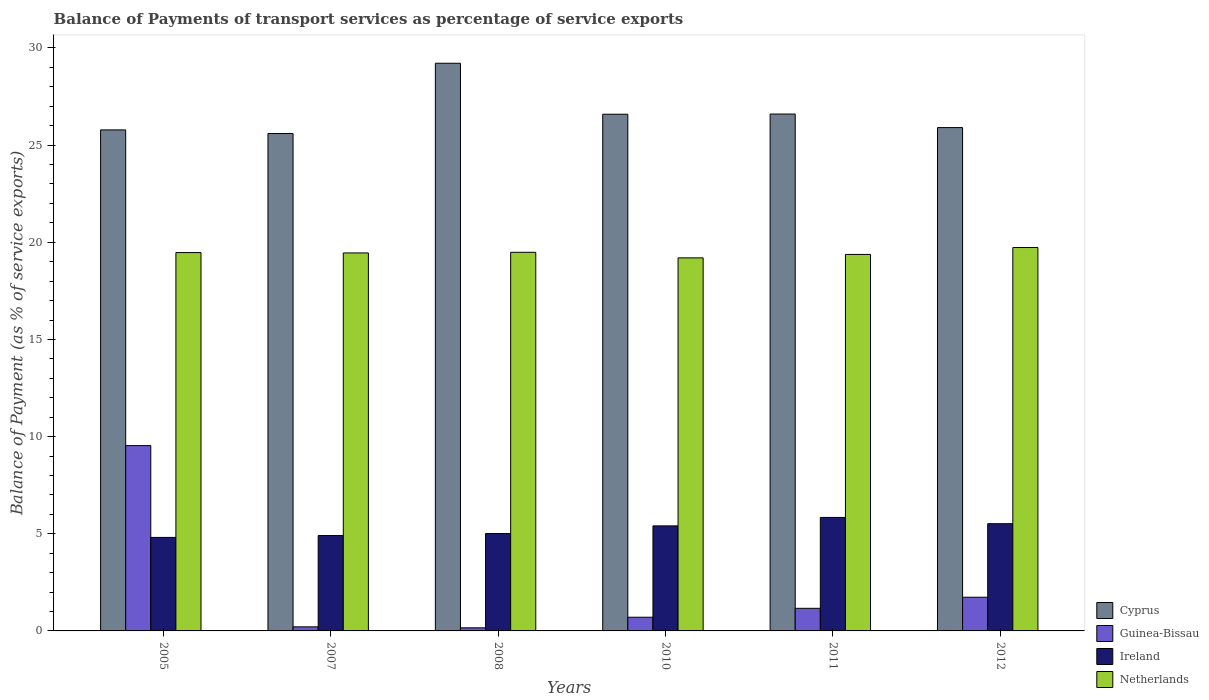Are the number of bars on each tick of the X-axis equal?
Keep it short and to the point. Yes. In how many cases, is the number of bars for a given year not equal to the number of legend labels?
Give a very brief answer. 0. What is the balance of payments of transport services in Netherlands in 2011?
Give a very brief answer. 19.37. Across all years, what is the maximum balance of payments of transport services in Netherlands?
Give a very brief answer. 19.73. Across all years, what is the minimum balance of payments of transport services in Ireland?
Give a very brief answer. 4.81. In which year was the balance of payments of transport services in Ireland maximum?
Ensure brevity in your answer.  2011. What is the total balance of payments of transport services in Ireland in the graph?
Your response must be concise. 31.5. What is the difference between the balance of payments of transport services in Guinea-Bissau in 2005 and that in 2011?
Keep it short and to the point. 8.37. What is the difference between the balance of payments of transport services in Netherlands in 2005 and the balance of payments of transport services in Ireland in 2012?
Provide a short and direct response. 13.95. What is the average balance of payments of transport services in Ireland per year?
Your response must be concise. 5.25. In the year 2007, what is the difference between the balance of payments of transport services in Cyprus and balance of payments of transport services in Netherlands?
Provide a succinct answer. 6.14. In how many years, is the balance of payments of transport services in Cyprus greater than 13 %?
Give a very brief answer. 6. What is the ratio of the balance of payments of transport services in Ireland in 2007 to that in 2012?
Provide a succinct answer. 0.89. Is the difference between the balance of payments of transport services in Cyprus in 2005 and 2012 greater than the difference between the balance of payments of transport services in Netherlands in 2005 and 2012?
Keep it short and to the point. Yes. What is the difference between the highest and the second highest balance of payments of transport services in Netherlands?
Ensure brevity in your answer.  0.25. What is the difference between the highest and the lowest balance of payments of transport services in Cyprus?
Offer a terse response. 3.62. In how many years, is the balance of payments of transport services in Netherlands greater than the average balance of payments of transport services in Netherlands taken over all years?
Your response must be concise. 4. Is the sum of the balance of payments of transport services in Ireland in 2007 and 2011 greater than the maximum balance of payments of transport services in Cyprus across all years?
Keep it short and to the point. No. Is it the case that in every year, the sum of the balance of payments of transport services in Cyprus and balance of payments of transport services in Ireland is greater than the sum of balance of payments of transport services in Guinea-Bissau and balance of payments of transport services in Netherlands?
Offer a very short reply. No. What does the 3rd bar from the left in 2012 represents?
Your answer should be very brief. Ireland. What does the 4th bar from the right in 2010 represents?
Provide a short and direct response. Cyprus. How many bars are there?
Your response must be concise. 24. What is the difference between two consecutive major ticks on the Y-axis?
Your answer should be very brief. 5. How many legend labels are there?
Your answer should be compact. 4. How are the legend labels stacked?
Your response must be concise. Vertical. What is the title of the graph?
Your answer should be very brief. Balance of Payments of transport services as percentage of service exports. What is the label or title of the Y-axis?
Your answer should be very brief. Balance of Payment (as % of service exports). What is the Balance of Payment (as % of service exports) of Cyprus in 2005?
Make the answer very short. 25.78. What is the Balance of Payment (as % of service exports) in Guinea-Bissau in 2005?
Make the answer very short. 9.54. What is the Balance of Payment (as % of service exports) of Ireland in 2005?
Give a very brief answer. 4.81. What is the Balance of Payment (as % of service exports) in Netherlands in 2005?
Make the answer very short. 19.47. What is the Balance of Payment (as % of service exports) of Cyprus in 2007?
Provide a short and direct response. 25.6. What is the Balance of Payment (as % of service exports) of Guinea-Bissau in 2007?
Provide a succinct answer. 0.21. What is the Balance of Payment (as % of service exports) in Ireland in 2007?
Give a very brief answer. 4.91. What is the Balance of Payment (as % of service exports) of Netherlands in 2007?
Make the answer very short. 19.45. What is the Balance of Payment (as % of service exports) in Cyprus in 2008?
Give a very brief answer. 29.21. What is the Balance of Payment (as % of service exports) of Guinea-Bissau in 2008?
Offer a terse response. 0.16. What is the Balance of Payment (as % of service exports) in Ireland in 2008?
Offer a terse response. 5.01. What is the Balance of Payment (as % of service exports) of Netherlands in 2008?
Provide a succinct answer. 19.48. What is the Balance of Payment (as % of service exports) in Cyprus in 2010?
Make the answer very short. 26.59. What is the Balance of Payment (as % of service exports) in Guinea-Bissau in 2010?
Make the answer very short. 0.7. What is the Balance of Payment (as % of service exports) in Ireland in 2010?
Keep it short and to the point. 5.4. What is the Balance of Payment (as % of service exports) in Netherlands in 2010?
Provide a succinct answer. 19.2. What is the Balance of Payment (as % of service exports) in Cyprus in 2011?
Ensure brevity in your answer.  26.6. What is the Balance of Payment (as % of service exports) in Guinea-Bissau in 2011?
Give a very brief answer. 1.16. What is the Balance of Payment (as % of service exports) in Ireland in 2011?
Offer a terse response. 5.84. What is the Balance of Payment (as % of service exports) in Netherlands in 2011?
Your answer should be compact. 19.37. What is the Balance of Payment (as % of service exports) of Cyprus in 2012?
Your answer should be compact. 25.9. What is the Balance of Payment (as % of service exports) of Guinea-Bissau in 2012?
Your response must be concise. 1.73. What is the Balance of Payment (as % of service exports) of Ireland in 2012?
Provide a short and direct response. 5.52. What is the Balance of Payment (as % of service exports) of Netherlands in 2012?
Keep it short and to the point. 19.73. Across all years, what is the maximum Balance of Payment (as % of service exports) in Cyprus?
Ensure brevity in your answer.  29.21. Across all years, what is the maximum Balance of Payment (as % of service exports) in Guinea-Bissau?
Your answer should be compact. 9.54. Across all years, what is the maximum Balance of Payment (as % of service exports) of Ireland?
Your response must be concise. 5.84. Across all years, what is the maximum Balance of Payment (as % of service exports) of Netherlands?
Offer a terse response. 19.73. Across all years, what is the minimum Balance of Payment (as % of service exports) of Cyprus?
Keep it short and to the point. 25.6. Across all years, what is the minimum Balance of Payment (as % of service exports) of Guinea-Bissau?
Ensure brevity in your answer.  0.16. Across all years, what is the minimum Balance of Payment (as % of service exports) in Ireland?
Give a very brief answer. 4.81. Across all years, what is the minimum Balance of Payment (as % of service exports) of Netherlands?
Your response must be concise. 19.2. What is the total Balance of Payment (as % of service exports) in Cyprus in the graph?
Offer a terse response. 159.68. What is the total Balance of Payment (as % of service exports) of Guinea-Bissau in the graph?
Your response must be concise. 13.51. What is the total Balance of Payment (as % of service exports) of Ireland in the graph?
Offer a very short reply. 31.5. What is the total Balance of Payment (as % of service exports) in Netherlands in the graph?
Ensure brevity in your answer.  116.71. What is the difference between the Balance of Payment (as % of service exports) of Cyprus in 2005 and that in 2007?
Give a very brief answer. 0.19. What is the difference between the Balance of Payment (as % of service exports) of Guinea-Bissau in 2005 and that in 2007?
Keep it short and to the point. 9.33. What is the difference between the Balance of Payment (as % of service exports) of Ireland in 2005 and that in 2007?
Offer a terse response. -0.1. What is the difference between the Balance of Payment (as % of service exports) in Netherlands in 2005 and that in 2007?
Your response must be concise. 0.02. What is the difference between the Balance of Payment (as % of service exports) of Cyprus in 2005 and that in 2008?
Provide a short and direct response. -3.43. What is the difference between the Balance of Payment (as % of service exports) in Guinea-Bissau in 2005 and that in 2008?
Ensure brevity in your answer.  9.38. What is the difference between the Balance of Payment (as % of service exports) in Ireland in 2005 and that in 2008?
Ensure brevity in your answer.  -0.2. What is the difference between the Balance of Payment (as % of service exports) of Netherlands in 2005 and that in 2008?
Your answer should be compact. -0.01. What is the difference between the Balance of Payment (as % of service exports) in Cyprus in 2005 and that in 2010?
Keep it short and to the point. -0.81. What is the difference between the Balance of Payment (as % of service exports) of Guinea-Bissau in 2005 and that in 2010?
Your response must be concise. 8.83. What is the difference between the Balance of Payment (as % of service exports) of Ireland in 2005 and that in 2010?
Your answer should be compact. -0.59. What is the difference between the Balance of Payment (as % of service exports) in Netherlands in 2005 and that in 2010?
Offer a terse response. 0.27. What is the difference between the Balance of Payment (as % of service exports) of Cyprus in 2005 and that in 2011?
Keep it short and to the point. -0.82. What is the difference between the Balance of Payment (as % of service exports) in Guinea-Bissau in 2005 and that in 2011?
Your response must be concise. 8.37. What is the difference between the Balance of Payment (as % of service exports) of Ireland in 2005 and that in 2011?
Make the answer very short. -1.03. What is the difference between the Balance of Payment (as % of service exports) in Netherlands in 2005 and that in 2011?
Your response must be concise. 0.1. What is the difference between the Balance of Payment (as % of service exports) of Cyprus in 2005 and that in 2012?
Offer a terse response. -0.12. What is the difference between the Balance of Payment (as % of service exports) in Guinea-Bissau in 2005 and that in 2012?
Your response must be concise. 7.8. What is the difference between the Balance of Payment (as % of service exports) in Ireland in 2005 and that in 2012?
Your answer should be compact. -0.71. What is the difference between the Balance of Payment (as % of service exports) in Netherlands in 2005 and that in 2012?
Provide a short and direct response. -0.26. What is the difference between the Balance of Payment (as % of service exports) in Cyprus in 2007 and that in 2008?
Ensure brevity in your answer.  -3.62. What is the difference between the Balance of Payment (as % of service exports) of Guinea-Bissau in 2007 and that in 2008?
Offer a terse response. 0.05. What is the difference between the Balance of Payment (as % of service exports) of Ireland in 2007 and that in 2008?
Ensure brevity in your answer.  -0.1. What is the difference between the Balance of Payment (as % of service exports) of Netherlands in 2007 and that in 2008?
Make the answer very short. -0.03. What is the difference between the Balance of Payment (as % of service exports) of Cyprus in 2007 and that in 2010?
Offer a terse response. -0.99. What is the difference between the Balance of Payment (as % of service exports) of Guinea-Bissau in 2007 and that in 2010?
Keep it short and to the point. -0.5. What is the difference between the Balance of Payment (as % of service exports) in Ireland in 2007 and that in 2010?
Offer a very short reply. -0.5. What is the difference between the Balance of Payment (as % of service exports) in Netherlands in 2007 and that in 2010?
Provide a short and direct response. 0.25. What is the difference between the Balance of Payment (as % of service exports) of Cyprus in 2007 and that in 2011?
Offer a very short reply. -1. What is the difference between the Balance of Payment (as % of service exports) in Guinea-Bissau in 2007 and that in 2011?
Ensure brevity in your answer.  -0.95. What is the difference between the Balance of Payment (as % of service exports) of Ireland in 2007 and that in 2011?
Offer a terse response. -0.93. What is the difference between the Balance of Payment (as % of service exports) in Netherlands in 2007 and that in 2011?
Provide a succinct answer. 0.08. What is the difference between the Balance of Payment (as % of service exports) in Cyprus in 2007 and that in 2012?
Offer a very short reply. -0.31. What is the difference between the Balance of Payment (as % of service exports) in Guinea-Bissau in 2007 and that in 2012?
Give a very brief answer. -1.52. What is the difference between the Balance of Payment (as % of service exports) of Ireland in 2007 and that in 2012?
Ensure brevity in your answer.  -0.61. What is the difference between the Balance of Payment (as % of service exports) of Netherlands in 2007 and that in 2012?
Give a very brief answer. -0.28. What is the difference between the Balance of Payment (as % of service exports) in Cyprus in 2008 and that in 2010?
Your answer should be compact. 2.62. What is the difference between the Balance of Payment (as % of service exports) in Guinea-Bissau in 2008 and that in 2010?
Offer a terse response. -0.54. What is the difference between the Balance of Payment (as % of service exports) in Ireland in 2008 and that in 2010?
Your answer should be compact. -0.39. What is the difference between the Balance of Payment (as % of service exports) of Netherlands in 2008 and that in 2010?
Make the answer very short. 0.29. What is the difference between the Balance of Payment (as % of service exports) in Cyprus in 2008 and that in 2011?
Offer a terse response. 2.61. What is the difference between the Balance of Payment (as % of service exports) in Guinea-Bissau in 2008 and that in 2011?
Keep it short and to the point. -1. What is the difference between the Balance of Payment (as % of service exports) in Ireland in 2008 and that in 2011?
Keep it short and to the point. -0.83. What is the difference between the Balance of Payment (as % of service exports) of Netherlands in 2008 and that in 2011?
Ensure brevity in your answer.  0.11. What is the difference between the Balance of Payment (as % of service exports) in Cyprus in 2008 and that in 2012?
Offer a terse response. 3.31. What is the difference between the Balance of Payment (as % of service exports) in Guinea-Bissau in 2008 and that in 2012?
Offer a terse response. -1.57. What is the difference between the Balance of Payment (as % of service exports) in Ireland in 2008 and that in 2012?
Make the answer very short. -0.51. What is the difference between the Balance of Payment (as % of service exports) of Netherlands in 2008 and that in 2012?
Offer a terse response. -0.25. What is the difference between the Balance of Payment (as % of service exports) of Cyprus in 2010 and that in 2011?
Make the answer very short. -0.01. What is the difference between the Balance of Payment (as % of service exports) in Guinea-Bissau in 2010 and that in 2011?
Offer a very short reply. -0.46. What is the difference between the Balance of Payment (as % of service exports) in Ireland in 2010 and that in 2011?
Offer a terse response. -0.44. What is the difference between the Balance of Payment (as % of service exports) in Netherlands in 2010 and that in 2011?
Provide a short and direct response. -0.18. What is the difference between the Balance of Payment (as % of service exports) in Cyprus in 2010 and that in 2012?
Your answer should be very brief. 0.69. What is the difference between the Balance of Payment (as % of service exports) of Guinea-Bissau in 2010 and that in 2012?
Give a very brief answer. -1.03. What is the difference between the Balance of Payment (as % of service exports) in Ireland in 2010 and that in 2012?
Ensure brevity in your answer.  -0.11. What is the difference between the Balance of Payment (as % of service exports) of Netherlands in 2010 and that in 2012?
Offer a terse response. -0.53. What is the difference between the Balance of Payment (as % of service exports) of Cyprus in 2011 and that in 2012?
Offer a terse response. 0.7. What is the difference between the Balance of Payment (as % of service exports) of Guinea-Bissau in 2011 and that in 2012?
Your answer should be very brief. -0.57. What is the difference between the Balance of Payment (as % of service exports) in Ireland in 2011 and that in 2012?
Give a very brief answer. 0.32. What is the difference between the Balance of Payment (as % of service exports) in Netherlands in 2011 and that in 2012?
Offer a terse response. -0.36. What is the difference between the Balance of Payment (as % of service exports) of Cyprus in 2005 and the Balance of Payment (as % of service exports) of Guinea-Bissau in 2007?
Make the answer very short. 25.57. What is the difference between the Balance of Payment (as % of service exports) of Cyprus in 2005 and the Balance of Payment (as % of service exports) of Ireland in 2007?
Your answer should be very brief. 20.87. What is the difference between the Balance of Payment (as % of service exports) of Cyprus in 2005 and the Balance of Payment (as % of service exports) of Netherlands in 2007?
Your response must be concise. 6.33. What is the difference between the Balance of Payment (as % of service exports) in Guinea-Bissau in 2005 and the Balance of Payment (as % of service exports) in Ireland in 2007?
Give a very brief answer. 4.63. What is the difference between the Balance of Payment (as % of service exports) of Guinea-Bissau in 2005 and the Balance of Payment (as % of service exports) of Netherlands in 2007?
Offer a very short reply. -9.91. What is the difference between the Balance of Payment (as % of service exports) of Ireland in 2005 and the Balance of Payment (as % of service exports) of Netherlands in 2007?
Offer a very short reply. -14.64. What is the difference between the Balance of Payment (as % of service exports) of Cyprus in 2005 and the Balance of Payment (as % of service exports) of Guinea-Bissau in 2008?
Keep it short and to the point. 25.62. What is the difference between the Balance of Payment (as % of service exports) in Cyprus in 2005 and the Balance of Payment (as % of service exports) in Ireland in 2008?
Offer a very short reply. 20.77. What is the difference between the Balance of Payment (as % of service exports) in Cyprus in 2005 and the Balance of Payment (as % of service exports) in Netherlands in 2008?
Provide a short and direct response. 6.3. What is the difference between the Balance of Payment (as % of service exports) in Guinea-Bissau in 2005 and the Balance of Payment (as % of service exports) in Ireland in 2008?
Offer a very short reply. 4.53. What is the difference between the Balance of Payment (as % of service exports) of Guinea-Bissau in 2005 and the Balance of Payment (as % of service exports) of Netherlands in 2008?
Provide a succinct answer. -9.95. What is the difference between the Balance of Payment (as % of service exports) in Ireland in 2005 and the Balance of Payment (as % of service exports) in Netherlands in 2008?
Offer a very short reply. -14.67. What is the difference between the Balance of Payment (as % of service exports) of Cyprus in 2005 and the Balance of Payment (as % of service exports) of Guinea-Bissau in 2010?
Your response must be concise. 25.08. What is the difference between the Balance of Payment (as % of service exports) in Cyprus in 2005 and the Balance of Payment (as % of service exports) in Ireland in 2010?
Ensure brevity in your answer.  20.38. What is the difference between the Balance of Payment (as % of service exports) of Cyprus in 2005 and the Balance of Payment (as % of service exports) of Netherlands in 2010?
Offer a terse response. 6.59. What is the difference between the Balance of Payment (as % of service exports) of Guinea-Bissau in 2005 and the Balance of Payment (as % of service exports) of Ireland in 2010?
Give a very brief answer. 4.13. What is the difference between the Balance of Payment (as % of service exports) of Guinea-Bissau in 2005 and the Balance of Payment (as % of service exports) of Netherlands in 2010?
Provide a short and direct response. -9.66. What is the difference between the Balance of Payment (as % of service exports) in Ireland in 2005 and the Balance of Payment (as % of service exports) in Netherlands in 2010?
Give a very brief answer. -14.38. What is the difference between the Balance of Payment (as % of service exports) in Cyprus in 2005 and the Balance of Payment (as % of service exports) in Guinea-Bissau in 2011?
Provide a short and direct response. 24.62. What is the difference between the Balance of Payment (as % of service exports) in Cyprus in 2005 and the Balance of Payment (as % of service exports) in Ireland in 2011?
Provide a short and direct response. 19.94. What is the difference between the Balance of Payment (as % of service exports) in Cyprus in 2005 and the Balance of Payment (as % of service exports) in Netherlands in 2011?
Your answer should be very brief. 6.41. What is the difference between the Balance of Payment (as % of service exports) of Guinea-Bissau in 2005 and the Balance of Payment (as % of service exports) of Ireland in 2011?
Your answer should be very brief. 3.7. What is the difference between the Balance of Payment (as % of service exports) of Guinea-Bissau in 2005 and the Balance of Payment (as % of service exports) of Netherlands in 2011?
Your answer should be very brief. -9.84. What is the difference between the Balance of Payment (as % of service exports) in Ireland in 2005 and the Balance of Payment (as % of service exports) in Netherlands in 2011?
Make the answer very short. -14.56. What is the difference between the Balance of Payment (as % of service exports) in Cyprus in 2005 and the Balance of Payment (as % of service exports) in Guinea-Bissau in 2012?
Provide a succinct answer. 24.05. What is the difference between the Balance of Payment (as % of service exports) in Cyprus in 2005 and the Balance of Payment (as % of service exports) in Ireland in 2012?
Provide a short and direct response. 20.26. What is the difference between the Balance of Payment (as % of service exports) of Cyprus in 2005 and the Balance of Payment (as % of service exports) of Netherlands in 2012?
Offer a very short reply. 6.05. What is the difference between the Balance of Payment (as % of service exports) of Guinea-Bissau in 2005 and the Balance of Payment (as % of service exports) of Ireland in 2012?
Your answer should be very brief. 4.02. What is the difference between the Balance of Payment (as % of service exports) in Guinea-Bissau in 2005 and the Balance of Payment (as % of service exports) in Netherlands in 2012?
Offer a very short reply. -10.19. What is the difference between the Balance of Payment (as % of service exports) in Ireland in 2005 and the Balance of Payment (as % of service exports) in Netherlands in 2012?
Your answer should be compact. -14.92. What is the difference between the Balance of Payment (as % of service exports) of Cyprus in 2007 and the Balance of Payment (as % of service exports) of Guinea-Bissau in 2008?
Your answer should be compact. 25.44. What is the difference between the Balance of Payment (as % of service exports) in Cyprus in 2007 and the Balance of Payment (as % of service exports) in Ireland in 2008?
Your answer should be very brief. 20.58. What is the difference between the Balance of Payment (as % of service exports) of Cyprus in 2007 and the Balance of Payment (as % of service exports) of Netherlands in 2008?
Your answer should be compact. 6.11. What is the difference between the Balance of Payment (as % of service exports) of Guinea-Bissau in 2007 and the Balance of Payment (as % of service exports) of Ireland in 2008?
Make the answer very short. -4.8. What is the difference between the Balance of Payment (as % of service exports) in Guinea-Bissau in 2007 and the Balance of Payment (as % of service exports) in Netherlands in 2008?
Offer a terse response. -19.27. What is the difference between the Balance of Payment (as % of service exports) in Ireland in 2007 and the Balance of Payment (as % of service exports) in Netherlands in 2008?
Give a very brief answer. -14.58. What is the difference between the Balance of Payment (as % of service exports) in Cyprus in 2007 and the Balance of Payment (as % of service exports) in Guinea-Bissau in 2010?
Give a very brief answer. 24.89. What is the difference between the Balance of Payment (as % of service exports) of Cyprus in 2007 and the Balance of Payment (as % of service exports) of Ireland in 2010?
Provide a short and direct response. 20.19. What is the difference between the Balance of Payment (as % of service exports) in Cyprus in 2007 and the Balance of Payment (as % of service exports) in Netherlands in 2010?
Your answer should be very brief. 6.4. What is the difference between the Balance of Payment (as % of service exports) in Guinea-Bissau in 2007 and the Balance of Payment (as % of service exports) in Ireland in 2010?
Your answer should be compact. -5.2. What is the difference between the Balance of Payment (as % of service exports) of Guinea-Bissau in 2007 and the Balance of Payment (as % of service exports) of Netherlands in 2010?
Make the answer very short. -18.99. What is the difference between the Balance of Payment (as % of service exports) of Ireland in 2007 and the Balance of Payment (as % of service exports) of Netherlands in 2010?
Make the answer very short. -14.29. What is the difference between the Balance of Payment (as % of service exports) in Cyprus in 2007 and the Balance of Payment (as % of service exports) in Guinea-Bissau in 2011?
Ensure brevity in your answer.  24.43. What is the difference between the Balance of Payment (as % of service exports) in Cyprus in 2007 and the Balance of Payment (as % of service exports) in Ireland in 2011?
Ensure brevity in your answer.  19.75. What is the difference between the Balance of Payment (as % of service exports) of Cyprus in 2007 and the Balance of Payment (as % of service exports) of Netherlands in 2011?
Offer a terse response. 6.22. What is the difference between the Balance of Payment (as % of service exports) in Guinea-Bissau in 2007 and the Balance of Payment (as % of service exports) in Ireland in 2011?
Your answer should be very brief. -5.63. What is the difference between the Balance of Payment (as % of service exports) of Guinea-Bissau in 2007 and the Balance of Payment (as % of service exports) of Netherlands in 2011?
Give a very brief answer. -19.16. What is the difference between the Balance of Payment (as % of service exports) of Ireland in 2007 and the Balance of Payment (as % of service exports) of Netherlands in 2011?
Give a very brief answer. -14.47. What is the difference between the Balance of Payment (as % of service exports) in Cyprus in 2007 and the Balance of Payment (as % of service exports) in Guinea-Bissau in 2012?
Provide a short and direct response. 23.86. What is the difference between the Balance of Payment (as % of service exports) in Cyprus in 2007 and the Balance of Payment (as % of service exports) in Ireland in 2012?
Keep it short and to the point. 20.08. What is the difference between the Balance of Payment (as % of service exports) in Cyprus in 2007 and the Balance of Payment (as % of service exports) in Netherlands in 2012?
Provide a succinct answer. 5.87. What is the difference between the Balance of Payment (as % of service exports) in Guinea-Bissau in 2007 and the Balance of Payment (as % of service exports) in Ireland in 2012?
Give a very brief answer. -5.31. What is the difference between the Balance of Payment (as % of service exports) in Guinea-Bissau in 2007 and the Balance of Payment (as % of service exports) in Netherlands in 2012?
Provide a succinct answer. -19.52. What is the difference between the Balance of Payment (as % of service exports) in Ireland in 2007 and the Balance of Payment (as % of service exports) in Netherlands in 2012?
Make the answer very short. -14.82. What is the difference between the Balance of Payment (as % of service exports) of Cyprus in 2008 and the Balance of Payment (as % of service exports) of Guinea-Bissau in 2010?
Provide a succinct answer. 28.51. What is the difference between the Balance of Payment (as % of service exports) in Cyprus in 2008 and the Balance of Payment (as % of service exports) in Ireland in 2010?
Ensure brevity in your answer.  23.81. What is the difference between the Balance of Payment (as % of service exports) of Cyprus in 2008 and the Balance of Payment (as % of service exports) of Netherlands in 2010?
Offer a terse response. 10.02. What is the difference between the Balance of Payment (as % of service exports) of Guinea-Bissau in 2008 and the Balance of Payment (as % of service exports) of Ireland in 2010?
Give a very brief answer. -5.25. What is the difference between the Balance of Payment (as % of service exports) of Guinea-Bissau in 2008 and the Balance of Payment (as % of service exports) of Netherlands in 2010?
Give a very brief answer. -19.04. What is the difference between the Balance of Payment (as % of service exports) in Ireland in 2008 and the Balance of Payment (as % of service exports) in Netherlands in 2010?
Provide a succinct answer. -14.18. What is the difference between the Balance of Payment (as % of service exports) in Cyprus in 2008 and the Balance of Payment (as % of service exports) in Guinea-Bissau in 2011?
Ensure brevity in your answer.  28.05. What is the difference between the Balance of Payment (as % of service exports) in Cyprus in 2008 and the Balance of Payment (as % of service exports) in Ireland in 2011?
Make the answer very short. 23.37. What is the difference between the Balance of Payment (as % of service exports) in Cyprus in 2008 and the Balance of Payment (as % of service exports) in Netherlands in 2011?
Provide a succinct answer. 9.84. What is the difference between the Balance of Payment (as % of service exports) in Guinea-Bissau in 2008 and the Balance of Payment (as % of service exports) in Ireland in 2011?
Provide a succinct answer. -5.68. What is the difference between the Balance of Payment (as % of service exports) in Guinea-Bissau in 2008 and the Balance of Payment (as % of service exports) in Netherlands in 2011?
Your answer should be very brief. -19.21. What is the difference between the Balance of Payment (as % of service exports) in Ireland in 2008 and the Balance of Payment (as % of service exports) in Netherlands in 2011?
Offer a terse response. -14.36. What is the difference between the Balance of Payment (as % of service exports) in Cyprus in 2008 and the Balance of Payment (as % of service exports) in Guinea-Bissau in 2012?
Make the answer very short. 27.48. What is the difference between the Balance of Payment (as % of service exports) in Cyprus in 2008 and the Balance of Payment (as % of service exports) in Ireland in 2012?
Your answer should be compact. 23.69. What is the difference between the Balance of Payment (as % of service exports) of Cyprus in 2008 and the Balance of Payment (as % of service exports) of Netherlands in 2012?
Ensure brevity in your answer.  9.48. What is the difference between the Balance of Payment (as % of service exports) of Guinea-Bissau in 2008 and the Balance of Payment (as % of service exports) of Ireland in 2012?
Keep it short and to the point. -5.36. What is the difference between the Balance of Payment (as % of service exports) of Guinea-Bissau in 2008 and the Balance of Payment (as % of service exports) of Netherlands in 2012?
Your answer should be compact. -19.57. What is the difference between the Balance of Payment (as % of service exports) of Ireland in 2008 and the Balance of Payment (as % of service exports) of Netherlands in 2012?
Provide a short and direct response. -14.72. What is the difference between the Balance of Payment (as % of service exports) of Cyprus in 2010 and the Balance of Payment (as % of service exports) of Guinea-Bissau in 2011?
Provide a short and direct response. 25.43. What is the difference between the Balance of Payment (as % of service exports) of Cyprus in 2010 and the Balance of Payment (as % of service exports) of Ireland in 2011?
Ensure brevity in your answer.  20.75. What is the difference between the Balance of Payment (as % of service exports) in Cyprus in 2010 and the Balance of Payment (as % of service exports) in Netherlands in 2011?
Keep it short and to the point. 7.22. What is the difference between the Balance of Payment (as % of service exports) of Guinea-Bissau in 2010 and the Balance of Payment (as % of service exports) of Ireland in 2011?
Offer a very short reply. -5.14. What is the difference between the Balance of Payment (as % of service exports) of Guinea-Bissau in 2010 and the Balance of Payment (as % of service exports) of Netherlands in 2011?
Provide a succinct answer. -18.67. What is the difference between the Balance of Payment (as % of service exports) in Ireland in 2010 and the Balance of Payment (as % of service exports) in Netherlands in 2011?
Give a very brief answer. -13.97. What is the difference between the Balance of Payment (as % of service exports) in Cyprus in 2010 and the Balance of Payment (as % of service exports) in Guinea-Bissau in 2012?
Offer a very short reply. 24.86. What is the difference between the Balance of Payment (as % of service exports) of Cyprus in 2010 and the Balance of Payment (as % of service exports) of Ireland in 2012?
Your response must be concise. 21.07. What is the difference between the Balance of Payment (as % of service exports) in Cyprus in 2010 and the Balance of Payment (as % of service exports) in Netherlands in 2012?
Make the answer very short. 6.86. What is the difference between the Balance of Payment (as % of service exports) of Guinea-Bissau in 2010 and the Balance of Payment (as % of service exports) of Ireland in 2012?
Give a very brief answer. -4.81. What is the difference between the Balance of Payment (as % of service exports) in Guinea-Bissau in 2010 and the Balance of Payment (as % of service exports) in Netherlands in 2012?
Keep it short and to the point. -19.03. What is the difference between the Balance of Payment (as % of service exports) of Ireland in 2010 and the Balance of Payment (as % of service exports) of Netherlands in 2012?
Make the answer very short. -14.32. What is the difference between the Balance of Payment (as % of service exports) of Cyprus in 2011 and the Balance of Payment (as % of service exports) of Guinea-Bissau in 2012?
Provide a succinct answer. 24.87. What is the difference between the Balance of Payment (as % of service exports) in Cyprus in 2011 and the Balance of Payment (as % of service exports) in Ireland in 2012?
Your answer should be compact. 21.08. What is the difference between the Balance of Payment (as % of service exports) in Cyprus in 2011 and the Balance of Payment (as % of service exports) in Netherlands in 2012?
Give a very brief answer. 6.87. What is the difference between the Balance of Payment (as % of service exports) in Guinea-Bissau in 2011 and the Balance of Payment (as % of service exports) in Ireland in 2012?
Keep it short and to the point. -4.36. What is the difference between the Balance of Payment (as % of service exports) in Guinea-Bissau in 2011 and the Balance of Payment (as % of service exports) in Netherlands in 2012?
Provide a succinct answer. -18.57. What is the difference between the Balance of Payment (as % of service exports) in Ireland in 2011 and the Balance of Payment (as % of service exports) in Netherlands in 2012?
Your response must be concise. -13.89. What is the average Balance of Payment (as % of service exports) in Cyprus per year?
Make the answer very short. 26.61. What is the average Balance of Payment (as % of service exports) of Guinea-Bissau per year?
Provide a short and direct response. 2.25. What is the average Balance of Payment (as % of service exports) in Ireland per year?
Offer a very short reply. 5.25. What is the average Balance of Payment (as % of service exports) of Netherlands per year?
Your answer should be compact. 19.45. In the year 2005, what is the difference between the Balance of Payment (as % of service exports) in Cyprus and Balance of Payment (as % of service exports) in Guinea-Bissau?
Offer a very short reply. 16.25. In the year 2005, what is the difference between the Balance of Payment (as % of service exports) of Cyprus and Balance of Payment (as % of service exports) of Ireland?
Keep it short and to the point. 20.97. In the year 2005, what is the difference between the Balance of Payment (as % of service exports) in Cyprus and Balance of Payment (as % of service exports) in Netherlands?
Provide a succinct answer. 6.31. In the year 2005, what is the difference between the Balance of Payment (as % of service exports) in Guinea-Bissau and Balance of Payment (as % of service exports) in Ireland?
Your answer should be very brief. 4.73. In the year 2005, what is the difference between the Balance of Payment (as % of service exports) in Guinea-Bissau and Balance of Payment (as % of service exports) in Netherlands?
Your answer should be very brief. -9.93. In the year 2005, what is the difference between the Balance of Payment (as % of service exports) of Ireland and Balance of Payment (as % of service exports) of Netherlands?
Your answer should be very brief. -14.66. In the year 2007, what is the difference between the Balance of Payment (as % of service exports) in Cyprus and Balance of Payment (as % of service exports) in Guinea-Bissau?
Give a very brief answer. 25.39. In the year 2007, what is the difference between the Balance of Payment (as % of service exports) in Cyprus and Balance of Payment (as % of service exports) in Ireland?
Give a very brief answer. 20.69. In the year 2007, what is the difference between the Balance of Payment (as % of service exports) in Cyprus and Balance of Payment (as % of service exports) in Netherlands?
Make the answer very short. 6.14. In the year 2007, what is the difference between the Balance of Payment (as % of service exports) of Guinea-Bissau and Balance of Payment (as % of service exports) of Ireland?
Make the answer very short. -4.7. In the year 2007, what is the difference between the Balance of Payment (as % of service exports) in Guinea-Bissau and Balance of Payment (as % of service exports) in Netherlands?
Offer a terse response. -19.24. In the year 2007, what is the difference between the Balance of Payment (as % of service exports) of Ireland and Balance of Payment (as % of service exports) of Netherlands?
Make the answer very short. -14.54. In the year 2008, what is the difference between the Balance of Payment (as % of service exports) of Cyprus and Balance of Payment (as % of service exports) of Guinea-Bissau?
Your answer should be very brief. 29.05. In the year 2008, what is the difference between the Balance of Payment (as % of service exports) in Cyprus and Balance of Payment (as % of service exports) in Ireland?
Provide a succinct answer. 24.2. In the year 2008, what is the difference between the Balance of Payment (as % of service exports) of Cyprus and Balance of Payment (as % of service exports) of Netherlands?
Provide a short and direct response. 9.73. In the year 2008, what is the difference between the Balance of Payment (as % of service exports) of Guinea-Bissau and Balance of Payment (as % of service exports) of Ireland?
Make the answer very short. -4.85. In the year 2008, what is the difference between the Balance of Payment (as % of service exports) of Guinea-Bissau and Balance of Payment (as % of service exports) of Netherlands?
Your answer should be compact. -19.32. In the year 2008, what is the difference between the Balance of Payment (as % of service exports) in Ireland and Balance of Payment (as % of service exports) in Netherlands?
Give a very brief answer. -14.47. In the year 2010, what is the difference between the Balance of Payment (as % of service exports) in Cyprus and Balance of Payment (as % of service exports) in Guinea-Bissau?
Provide a short and direct response. 25.88. In the year 2010, what is the difference between the Balance of Payment (as % of service exports) of Cyprus and Balance of Payment (as % of service exports) of Ireland?
Provide a succinct answer. 21.18. In the year 2010, what is the difference between the Balance of Payment (as % of service exports) of Cyprus and Balance of Payment (as % of service exports) of Netherlands?
Your response must be concise. 7.39. In the year 2010, what is the difference between the Balance of Payment (as % of service exports) of Guinea-Bissau and Balance of Payment (as % of service exports) of Ireland?
Give a very brief answer. -4.7. In the year 2010, what is the difference between the Balance of Payment (as % of service exports) in Guinea-Bissau and Balance of Payment (as % of service exports) in Netherlands?
Offer a terse response. -18.49. In the year 2010, what is the difference between the Balance of Payment (as % of service exports) in Ireland and Balance of Payment (as % of service exports) in Netherlands?
Provide a succinct answer. -13.79. In the year 2011, what is the difference between the Balance of Payment (as % of service exports) of Cyprus and Balance of Payment (as % of service exports) of Guinea-Bissau?
Your answer should be compact. 25.44. In the year 2011, what is the difference between the Balance of Payment (as % of service exports) of Cyprus and Balance of Payment (as % of service exports) of Ireland?
Give a very brief answer. 20.76. In the year 2011, what is the difference between the Balance of Payment (as % of service exports) in Cyprus and Balance of Payment (as % of service exports) in Netherlands?
Give a very brief answer. 7.22. In the year 2011, what is the difference between the Balance of Payment (as % of service exports) of Guinea-Bissau and Balance of Payment (as % of service exports) of Ireland?
Your answer should be very brief. -4.68. In the year 2011, what is the difference between the Balance of Payment (as % of service exports) in Guinea-Bissau and Balance of Payment (as % of service exports) in Netherlands?
Provide a short and direct response. -18.21. In the year 2011, what is the difference between the Balance of Payment (as % of service exports) in Ireland and Balance of Payment (as % of service exports) in Netherlands?
Offer a terse response. -13.53. In the year 2012, what is the difference between the Balance of Payment (as % of service exports) in Cyprus and Balance of Payment (as % of service exports) in Guinea-Bissau?
Provide a short and direct response. 24.17. In the year 2012, what is the difference between the Balance of Payment (as % of service exports) in Cyprus and Balance of Payment (as % of service exports) in Ireland?
Your answer should be very brief. 20.38. In the year 2012, what is the difference between the Balance of Payment (as % of service exports) in Cyprus and Balance of Payment (as % of service exports) in Netherlands?
Keep it short and to the point. 6.17. In the year 2012, what is the difference between the Balance of Payment (as % of service exports) in Guinea-Bissau and Balance of Payment (as % of service exports) in Ireland?
Offer a very short reply. -3.78. In the year 2012, what is the difference between the Balance of Payment (as % of service exports) of Guinea-Bissau and Balance of Payment (as % of service exports) of Netherlands?
Ensure brevity in your answer.  -18. In the year 2012, what is the difference between the Balance of Payment (as % of service exports) of Ireland and Balance of Payment (as % of service exports) of Netherlands?
Give a very brief answer. -14.21. What is the ratio of the Balance of Payment (as % of service exports) in Cyprus in 2005 to that in 2007?
Provide a succinct answer. 1.01. What is the ratio of the Balance of Payment (as % of service exports) in Guinea-Bissau in 2005 to that in 2007?
Make the answer very short. 45.5. What is the ratio of the Balance of Payment (as % of service exports) of Ireland in 2005 to that in 2007?
Your answer should be very brief. 0.98. What is the ratio of the Balance of Payment (as % of service exports) in Cyprus in 2005 to that in 2008?
Offer a terse response. 0.88. What is the ratio of the Balance of Payment (as % of service exports) of Guinea-Bissau in 2005 to that in 2008?
Provide a short and direct response. 59.64. What is the ratio of the Balance of Payment (as % of service exports) in Netherlands in 2005 to that in 2008?
Your answer should be compact. 1. What is the ratio of the Balance of Payment (as % of service exports) in Cyprus in 2005 to that in 2010?
Keep it short and to the point. 0.97. What is the ratio of the Balance of Payment (as % of service exports) of Guinea-Bissau in 2005 to that in 2010?
Provide a short and direct response. 13.53. What is the ratio of the Balance of Payment (as % of service exports) of Ireland in 2005 to that in 2010?
Keep it short and to the point. 0.89. What is the ratio of the Balance of Payment (as % of service exports) of Netherlands in 2005 to that in 2010?
Keep it short and to the point. 1.01. What is the ratio of the Balance of Payment (as % of service exports) of Cyprus in 2005 to that in 2011?
Give a very brief answer. 0.97. What is the ratio of the Balance of Payment (as % of service exports) in Guinea-Bissau in 2005 to that in 2011?
Give a very brief answer. 8.2. What is the ratio of the Balance of Payment (as % of service exports) in Ireland in 2005 to that in 2011?
Offer a terse response. 0.82. What is the ratio of the Balance of Payment (as % of service exports) of Guinea-Bissau in 2005 to that in 2012?
Offer a very short reply. 5.5. What is the ratio of the Balance of Payment (as % of service exports) in Ireland in 2005 to that in 2012?
Offer a terse response. 0.87. What is the ratio of the Balance of Payment (as % of service exports) of Netherlands in 2005 to that in 2012?
Provide a succinct answer. 0.99. What is the ratio of the Balance of Payment (as % of service exports) of Cyprus in 2007 to that in 2008?
Offer a terse response. 0.88. What is the ratio of the Balance of Payment (as % of service exports) of Guinea-Bissau in 2007 to that in 2008?
Keep it short and to the point. 1.31. What is the ratio of the Balance of Payment (as % of service exports) of Ireland in 2007 to that in 2008?
Your answer should be compact. 0.98. What is the ratio of the Balance of Payment (as % of service exports) in Cyprus in 2007 to that in 2010?
Make the answer very short. 0.96. What is the ratio of the Balance of Payment (as % of service exports) in Guinea-Bissau in 2007 to that in 2010?
Ensure brevity in your answer.  0.3. What is the ratio of the Balance of Payment (as % of service exports) of Ireland in 2007 to that in 2010?
Offer a terse response. 0.91. What is the ratio of the Balance of Payment (as % of service exports) in Netherlands in 2007 to that in 2010?
Your answer should be compact. 1.01. What is the ratio of the Balance of Payment (as % of service exports) in Cyprus in 2007 to that in 2011?
Your answer should be compact. 0.96. What is the ratio of the Balance of Payment (as % of service exports) in Guinea-Bissau in 2007 to that in 2011?
Provide a short and direct response. 0.18. What is the ratio of the Balance of Payment (as % of service exports) in Ireland in 2007 to that in 2011?
Your answer should be very brief. 0.84. What is the ratio of the Balance of Payment (as % of service exports) of Guinea-Bissau in 2007 to that in 2012?
Make the answer very short. 0.12. What is the ratio of the Balance of Payment (as % of service exports) in Ireland in 2007 to that in 2012?
Give a very brief answer. 0.89. What is the ratio of the Balance of Payment (as % of service exports) in Netherlands in 2007 to that in 2012?
Keep it short and to the point. 0.99. What is the ratio of the Balance of Payment (as % of service exports) of Cyprus in 2008 to that in 2010?
Keep it short and to the point. 1.1. What is the ratio of the Balance of Payment (as % of service exports) of Guinea-Bissau in 2008 to that in 2010?
Offer a terse response. 0.23. What is the ratio of the Balance of Payment (as % of service exports) of Ireland in 2008 to that in 2010?
Provide a succinct answer. 0.93. What is the ratio of the Balance of Payment (as % of service exports) in Netherlands in 2008 to that in 2010?
Keep it short and to the point. 1.01. What is the ratio of the Balance of Payment (as % of service exports) in Cyprus in 2008 to that in 2011?
Keep it short and to the point. 1.1. What is the ratio of the Balance of Payment (as % of service exports) of Guinea-Bissau in 2008 to that in 2011?
Offer a terse response. 0.14. What is the ratio of the Balance of Payment (as % of service exports) in Ireland in 2008 to that in 2011?
Provide a succinct answer. 0.86. What is the ratio of the Balance of Payment (as % of service exports) in Netherlands in 2008 to that in 2011?
Your response must be concise. 1.01. What is the ratio of the Balance of Payment (as % of service exports) in Cyprus in 2008 to that in 2012?
Make the answer very short. 1.13. What is the ratio of the Balance of Payment (as % of service exports) of Guinea-Bissau in 2008 to that in 2012?
Provide a succinct answer. 0.09. What is the ratio of the Balance of Payment (as % of service exports) in Ireland in 2008 to that in 2012?
Your answer should be compact. 0.91. What is the ratio of the Balance of Payment (as % of service exports) of Netherlands in 2008 to that in 2012?
Ensure brevity in your answer.  0.99. What is the ratio of the Balance of Payment (as % of service exports) of Cyprus in 2010 to that in 2011?
Offer a very short reply. 1. What is the ratio of the Balance of Payment (as % of service exports) in Guinea-Bissau in 2010 to that in 2011?
Your answer should be compact. 0.61. What is the ratio of the Balance of Payment (as % of service exports) of Ireland in 2010 to that in 2011?
Make the answer very short. 0.93. What is the ratio of the Balance of Payment (as % of service exports) in Netherlands in 2010 to that in 2011?
Provide a succinct answer. 0.99. What is the ratio of the Balance of Payment (as % of service exports) of Cyprus in 2010 to that in 2012?
Your answer should be very brief. 1.03. What is the ratio of the Balance of Payment (as % of service exports) in Guinea-Bissau in 2010 to that in 2012?
Ensure brevity in your answer.  0.41. What is the ratio of the Balance of Payment (as % of service exports) in Ireland in 2010 to that in 2012?
Your answer should be compact. 0.98. What is the ratio of the Balance of Payment (as % of service exports) in Netherlands in 2010 to that in 2012?
Give a very brief answer. 0.97. What is the ratio of the Balance of Payment (as % of service exports) in Cyprus in 2011 to that in 2012?
Your response must be concise. 1.03. What is the ratio of the Balance of Payment (as % of service exports) in Guinea-Bissau in 2011 to that in 2012?
Offer a terse response. 0.67. What is the ratio of the Balance of Payment (as % of service exports) in Ireland in 2011 to that in 2012?
Provide a succinct answer. 1.06. What is the difference between the highest and the second highest Balance of Payment (as % of service exports) in Cyprus?
Your response must be concise. 2.61. What is the difference between the highest and the second highest Balance of Payment (as % of service exports) of Guinea-Bissau?
Keep it short and to the point. 7.8. What is the difference between the highest and the second highest Balance of Payment (as % of service exports) of Ireland?
Provide a short and direct response. 0.32. What is the difference between the highest and the second highest Balance of Payment (as % of service exports) in Netherlands?
Make the answer very short. 0.25. What is the difference between the highest and the lowest Balance of Payment (as % of service exports) in Cyprus?
Make the answer very short. 3.62. What is the difference between the highest and the lowest Balance of Payment (as % of service exports) in Guinea-Bissau?
Your response must be concise. 9.38. What is the difference between the highest and the lowest Balance of Payment (as % of service exports) of Ireland?
Keep it short and to the point. 1.03. What is the difference between the highest and the lowest Balance of Payment (as % of service exports) of Netherlands?
Provide a short and direct response. 0.53. 